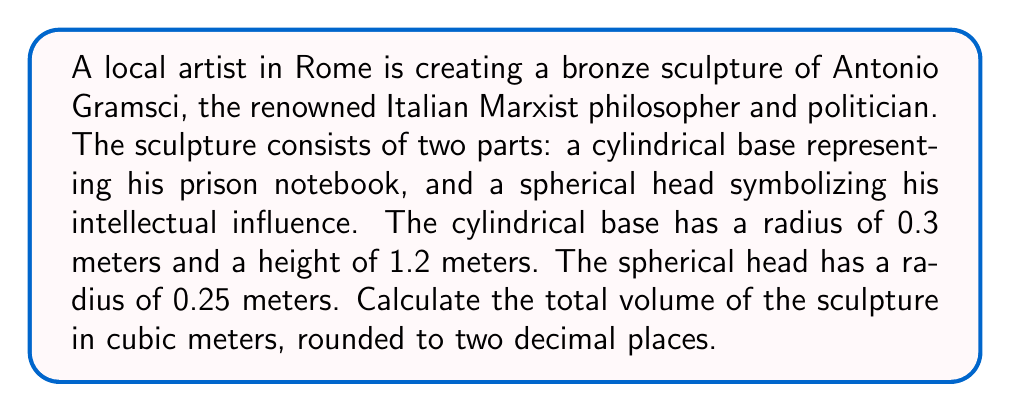Help me with this question. To solve this problem, we need to calculate the volumes of both parts of the sculpture and then add them together.

1. Volume of the cylindrical base:
   The formula for the volume of a cylinder is $V_{cylinder} = \pi r^2 h$
   Where $r$ is the radius and $h$ is the height.
   
   $$V_{cylinder} = \pi (0.3 \text{ m})^2 (1.2 \text{ m}) = 0.3392 \text{ m}^3$$

2. Volume of the spherical head:
   The formula for the volume of a sphere is $V_{sphere} = \frac{4}{3}\pi r^3$
   Where $r$ is the radius.
   
   $$V_{sphere} = \frac{4}{3}\pi (0.25 \text{ m})^3 = 0.0654 \text{ m}^3$$

3. Total volume:
   $$V_{total} = V_{cylinder} + V_{sphere} = 0.3392 \text{ m}^3 + 0.0654 \text{ m}^3 = 0.4046 \text{ m}^3$$

4. Rounding to two decimal places:
   $$V_{total} \approx 0.40 \text{ m}^3$$
Answer: The total volume of the sculpture is approximately 0.40 cubic meters. 